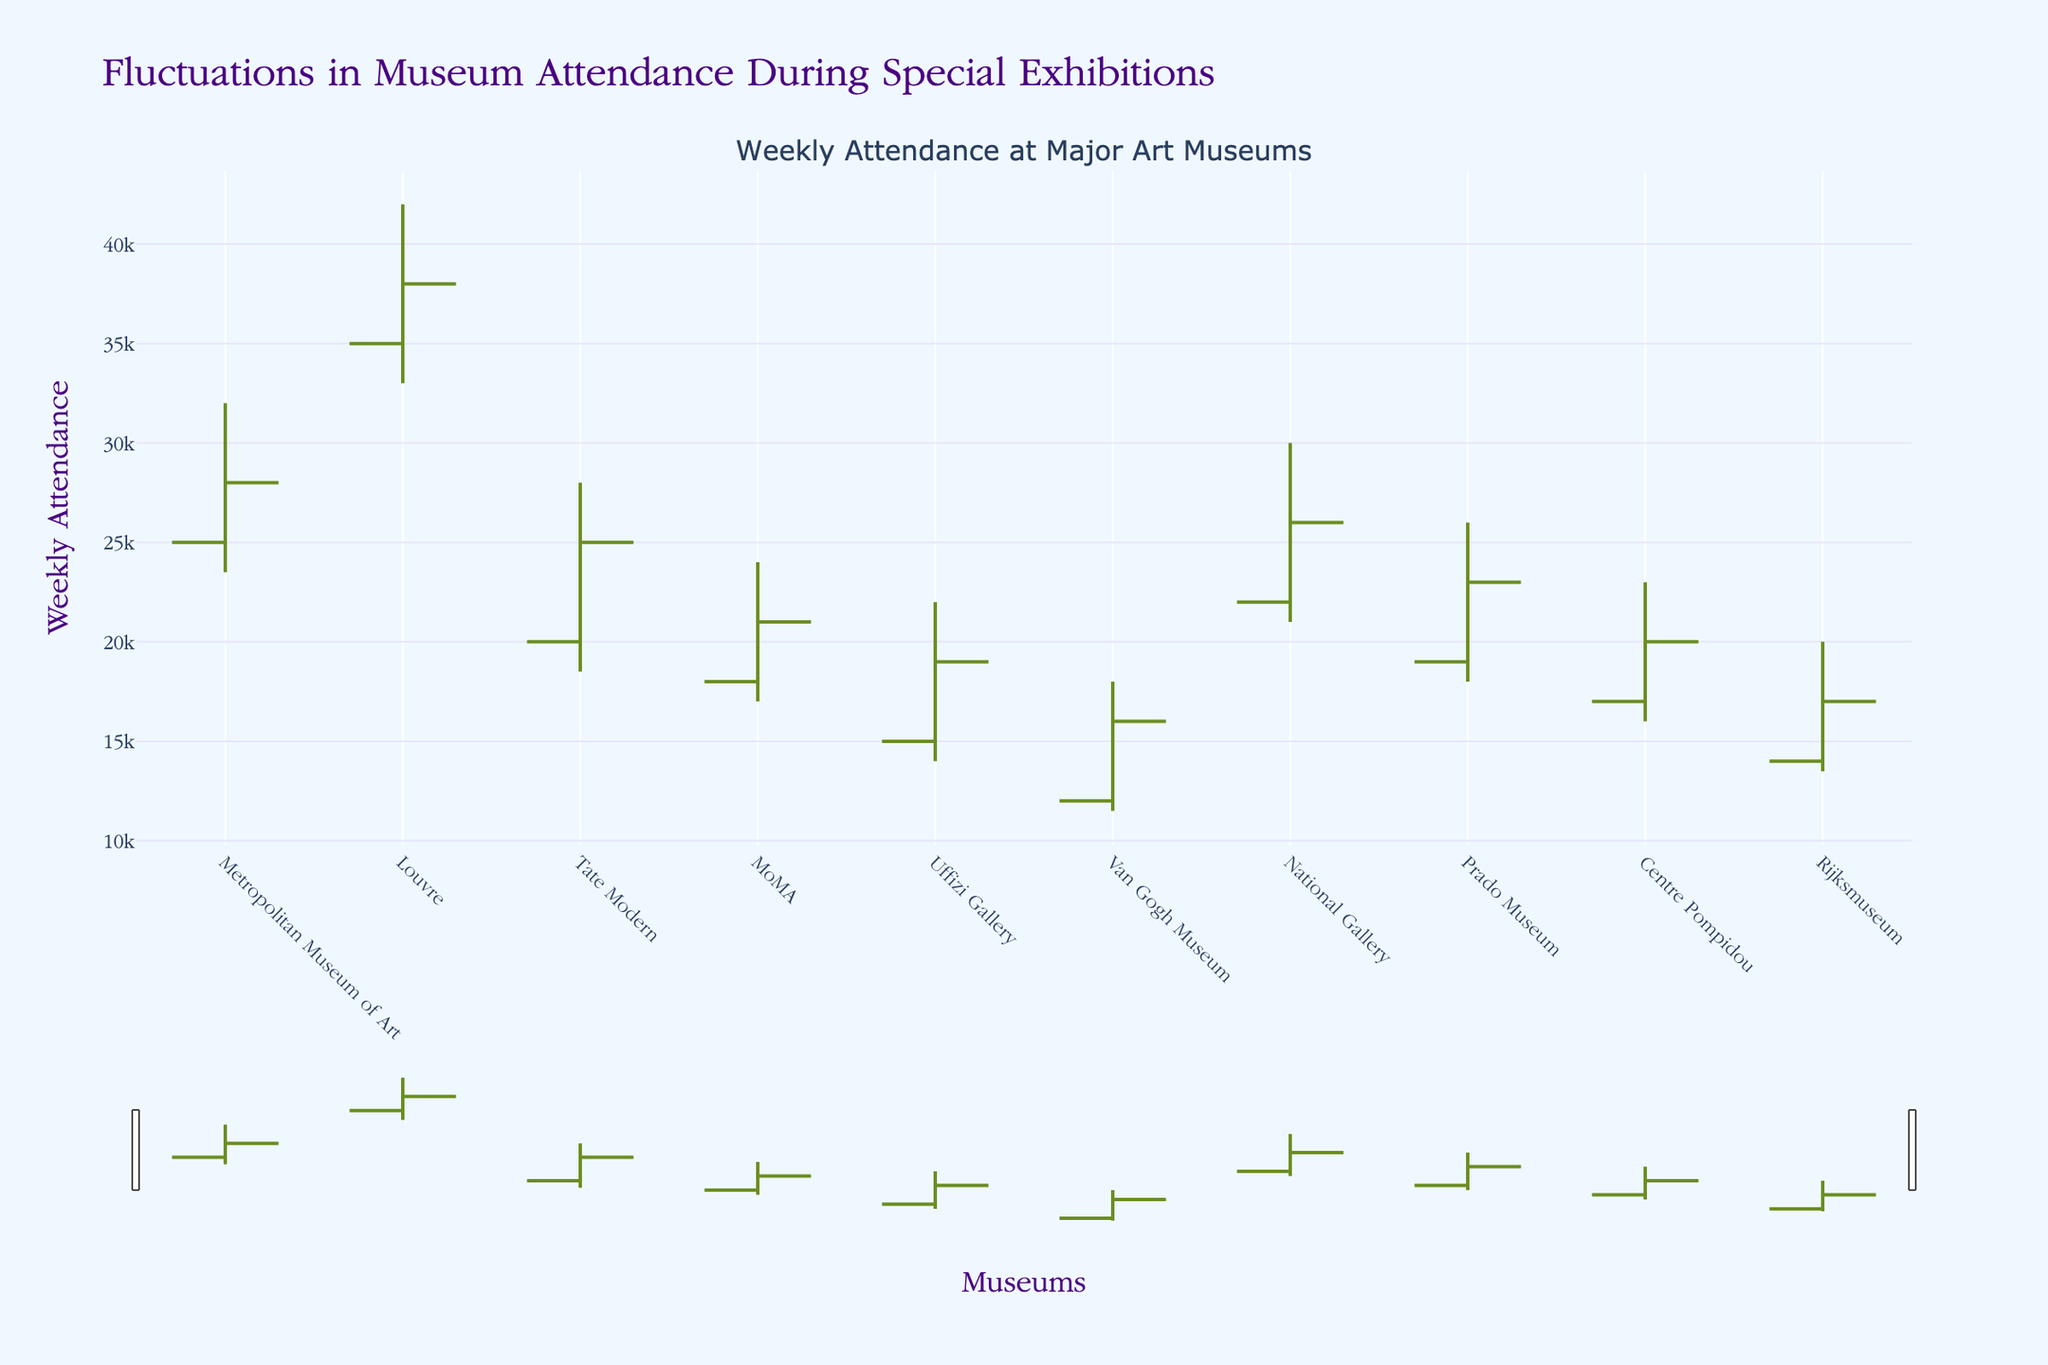What is the title of the figure? The title of the figure is usually displayed prominently at the top of the chart. In this case, it is written as the main descriptive text.
Answer: Fluctuations in Museum Attendance During Special Exhibitions Which museum had the highest weekly attendance at its peak? To answer this, look for the highest point on the y-axis among all the candlesticks. The "High" value for each museum indicates the peak attendance.
Answer: Louvre What is the difference between the 'Open' and 'Close' attendance figures for the Rijksmuseum? Locate the 'Open' and 'Close' values for the Rijksmuseum on the y-axis. Subtract the 'Open' value from the 'Close' value to get the difference.
Answer: 3000 How many museums had their 'High' attendance figures above 30,000? Count the number of candlesticks where the highest point (High value) is above the 30,000 mark on the y-axis.
Answer: 3 Which museum had the smallest range (difference between 'High' and 'Low') in attendance figures? Calculate the range for each museum by subtracting the 'Low' value from the 'High' value and identify the museum with the smallest result.
Answer: Rijksmuseum Compare the 'Open' attendance figures for the Metropolitan Museum of Art and the Van Gogh Museum. Which one had a higher opening attendance? Look at the 'Open' values for both museums and compare them. The one with the higher number has the higher opening attendance.
Answer: Metropolitan Museum of Art What is the average 'Close' attendance figure across all museums? Sum up the 'Close' attendance figures for all museums and divide by the number of museums (10 in this case) to get the average.
Answer: 23900 During which week's attendance figures did the Uffizi Gallery experience the biggest drop (highest 'High' to lowest 'Low')? Calculate the drop for each week by subtracting the 'Low' value from the 'High' value and identify the week with the largest drop.
Answer: Uffizi Gallery's week shows a drop from 22000 to 14000, i.e., 8000 What is the median attendance close value among all museums? To find the median, list all the 'Close' values in ascending order and find the middle value.
Answer: 22500 How does the attendance fluctuation of the Tate Modern compare to that of MoMA? Compare the difference between 'High' and 'Low' (fluctuation) values for both the Tate Modern and MoMA. The museum with the higher difference has greater fluctuation.
Answer: Tate Modern 